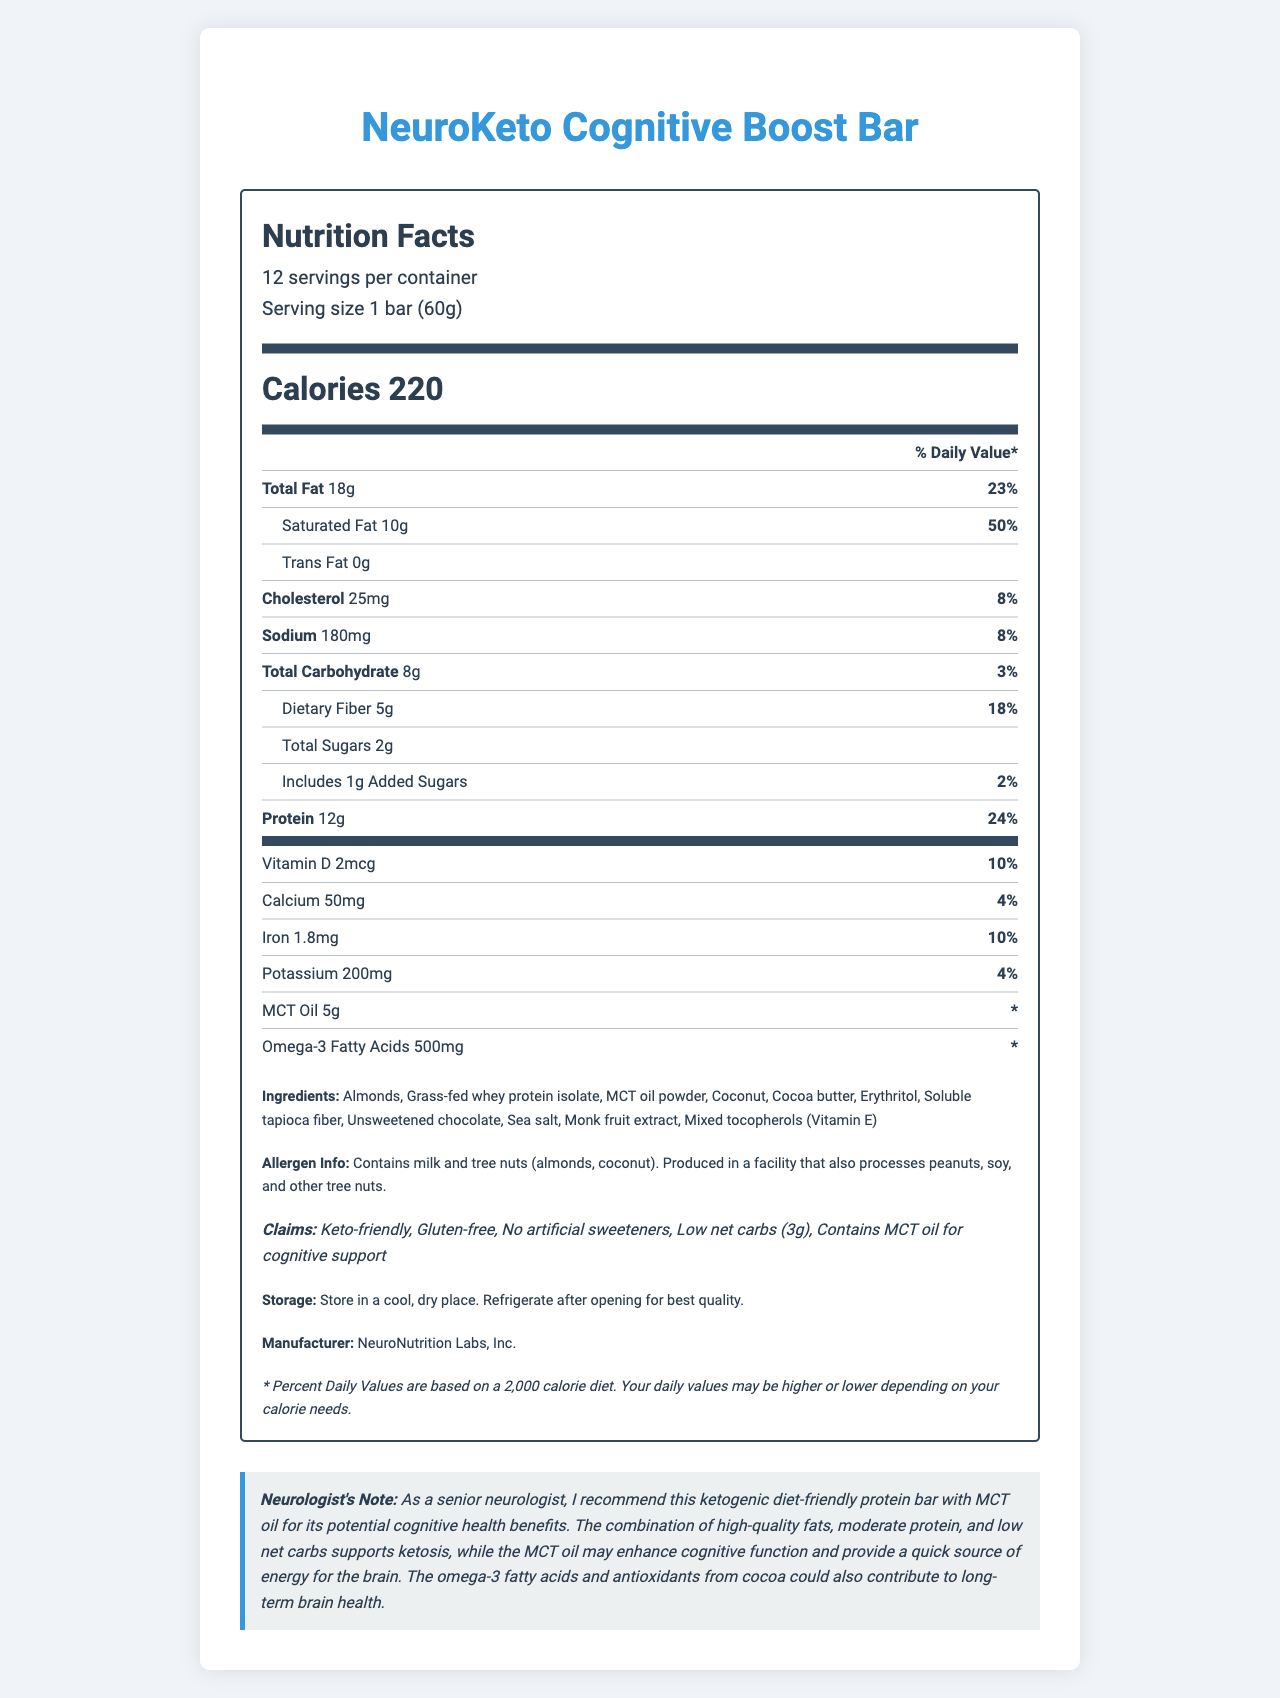what is the serving size? The document specifies that the serving size is "1 bar (60g)", found near the top of the nutrition facts section.
Answer: 1 bar (60g) how many servings are in a container? The document lists "12 servings per container" in the serving info section.
Answer: 12 how many calories are in a single serving? The "Calories" section indicates there are 220 calories per serving.
Answer: 220 what is the total fat content per serving and its daily value percentage? The total fat content is 18g with a daily value of 23%, as listed in the "Total Fat" section.
Answer: 18g, 23% How much protein is in one serving and what percent of the daily value does it represent? Each serving contains 12g of protein, representing 24% of the daily value.
Answer: 12g, 24% what amount of MCT oil is present per serving? MCT oil is listed with an amount of 5g per serving, but no daily value percentage is given.
Answer: 5g summarize the main nutritional benefits of the NeuroKeto Cognitive Boost Bar. The bar supports ketosis with high-quality fats, has moderate protein levels, low net carbs, and contains MCT oil for cognitive support and omega-3 fatty acids for brain health.
Answer: High fat, moderate protein, low net carbs, MCT oil for cognitive support, contains omega-3 fatty acids how much dietary fiber is in one serving and what is its daily value percentage? The total dietary fiber per serving is 5g, which represents 18% of the daily value.
Answer: 5g, 18% how much added sugar is in each bar? The document shows that each bar contains 1g of added sugars.
Answer: 1g what are the first three ingredients listed? The first three ingredients listed in the ingredients section are Almonds, Grass-fed whey protein isolate, and MCT oil powder.
Answer: Almonds, Grass-fed whey protein isolate, MCT oil powder which vitamin is present in the bar and what percent of the daily value does it provide? A. Vitamin A B. Vitamin B12 C. Vitamin D D. Vitamin C The bar contains Vitamin D, providing 10% of the daily value.
Answer: C. Vitamin D how much potassium is in each serving? Each serving of the bar contains 200mg of potassium.
Answer: 200mg does the NeuroKeto Cognitive Boost Bar contain any tree nuts? The allergen info specifies that the bar contains tree nuts (almonds, coconut).
Answer: Yes which nutrient has the highest daily value percentage in one serving? A. Saturated Fat B. Sodium C. Calcium D. Iron According to the document, saturated fat has the highest daily value percentage at 50%.
Answer: A. Saturated Fat how much cholesterol is in one serving and what percent of the daily value does it represent? Each serving contains 25mg of cholesterol, accounting for 8% of the daily value.
Answer: 25mg, 8% is the product labeled as gluten-free? Under the claims section, it specifies that the product is gluten-free.
Answer: Yes what are the potential cognitive health benefits mentioned by the neurologist? The neurologist notes that MCT oil may enhance cognitive function, provide quick brain energy, and that omega-3s and cocoa antioxidants contribute to long-term brain health.
Answer: MCT oil may enhance cognitive function and provide a quick source of energy for the brain, omega-3 fatty acids and antioxidants from cocoa contribute to long-term brain health. is the daily value percentage of omega-3 fatty acids listed? The daily value percentage for omega-3 fatty acids is not provided in the document.
Answer: No are there any artificial sweeteners in the product? The claims section mentions that there are no artificial sweeteners in the product.
Answer: No what is the storage recommendation for the NeuroKeto Cognitive Boost Bar? The storage section advises storing in a cool, dry place and refrigerating after opening for best quality.
Answer: Store in a cool, dry place. Refrigerate after opening for best quality. what are the main types of fat listed in the document and their amounts? The document lists 18g of total fat, 10g of saturated fat, and 0g of trans fat per serving.
Answer: Total Fat: 18g, Saturated Fat: 10g, Trans Fat: 0g who manufactures the NeuroKeto Cognitive Boost Bar? The manufacturer is stated to be NeuroNutrition Labs, Inc.
Answer: NeuroNutrition Labs, Inc. what percentage of the daily value of calcium is in one serving? One serving contains 4% of the daily value for calcium.
Answer: 4% what is the daily value percentage of iron in the bar? A. 2% B. 4% C. 10% D. 23% The document notes that iron in the bar represents 10% of the daily value.
Answer: C. 10% how much sodium is there per serving? The sodium content is listed as 180mg per serving.
Answer: 180mg how many grams of net carbs does each bar have? The bar has low net carbs, indicated as 3g in the claims section.
Answer: 3g what sweeteners are used in the NeuroKeto Cognitive Boost Bar? The ingredients list mentions erythritol and monk fruit extract as sweeteners.
Answer: Erythritol, Monk fruit extract can the cognitive benefits of the NeuroKeto Cognitive Boost Bar be guaranteed for everyone? The cognitive benefits are suggested but may vary based on individual responses to MCT oil and other ingredients.
Answer: Cannot be determined 